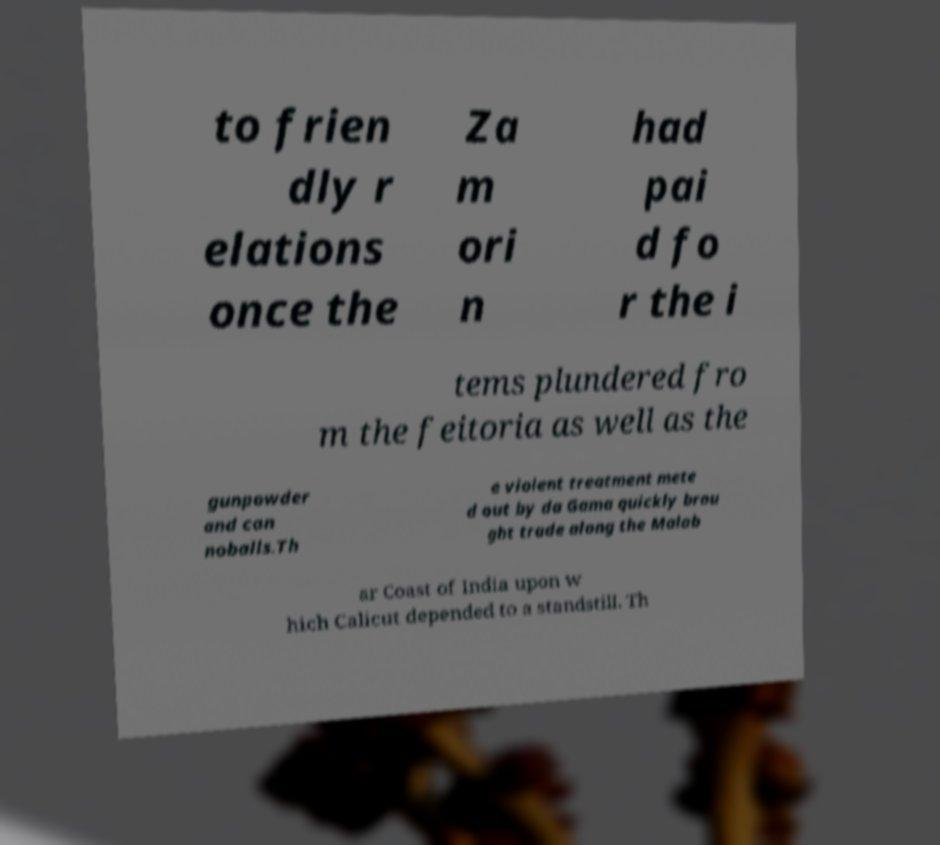What messages or text are displayed in this image? I need them in a readable, typed format. to frien dly r elations once the Za m ori n had pai d fo r the i tems plundered fro m the feitoria as well as the gunpowder and can noballs.Th e violent treatment mete d out by da Gama quickly brou ght trade along the Malab ar Coast of India upon w hich Calicut depended to a standstill. Th 